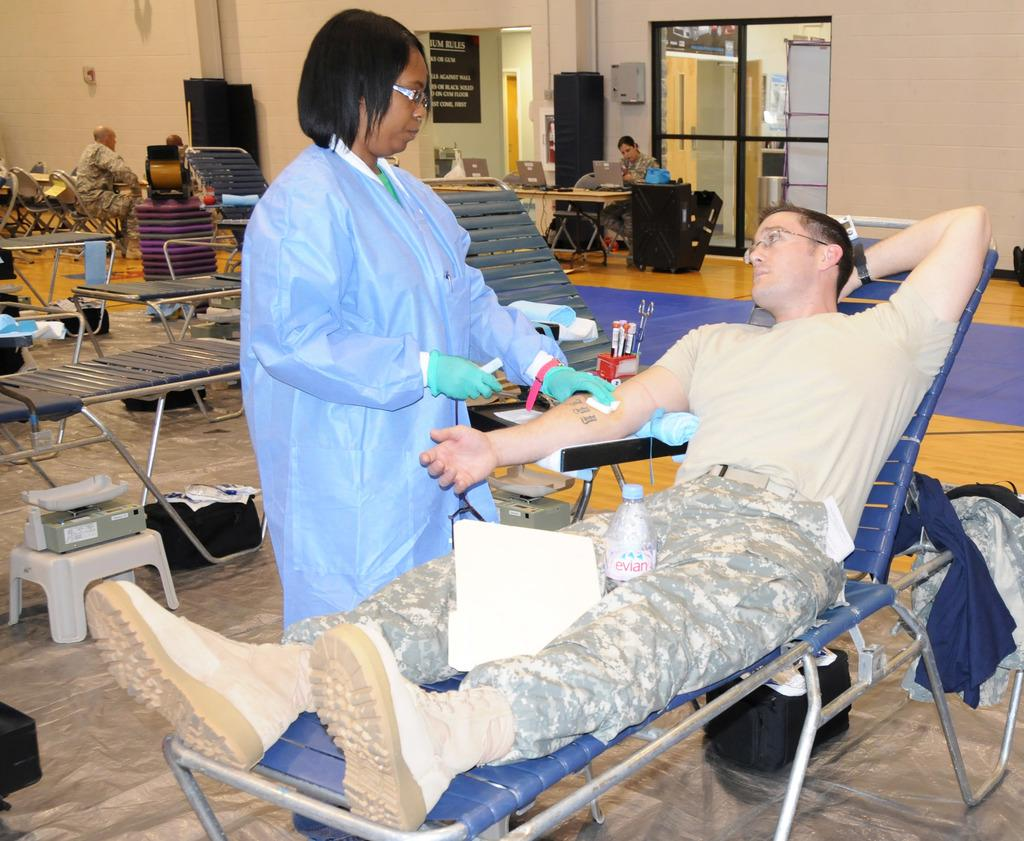What type of furniture is present in the room? There are beds and stools in the room. Are there any people in the room? Yes, there are people in the room. What is a person doing in the room? One person is sitting on a chair, and another person is lying on a bed. Is there any source of hydration in the room? Yes, there is a water bottle in the room. What feature allows natural light to enter the room? There is a window in the room in the room. What type of curtain is being shown in the image? There is no curtain present in the image. What is the person's mind doing in the image? The image does not show the person's mind; it only shows their physical actions. 